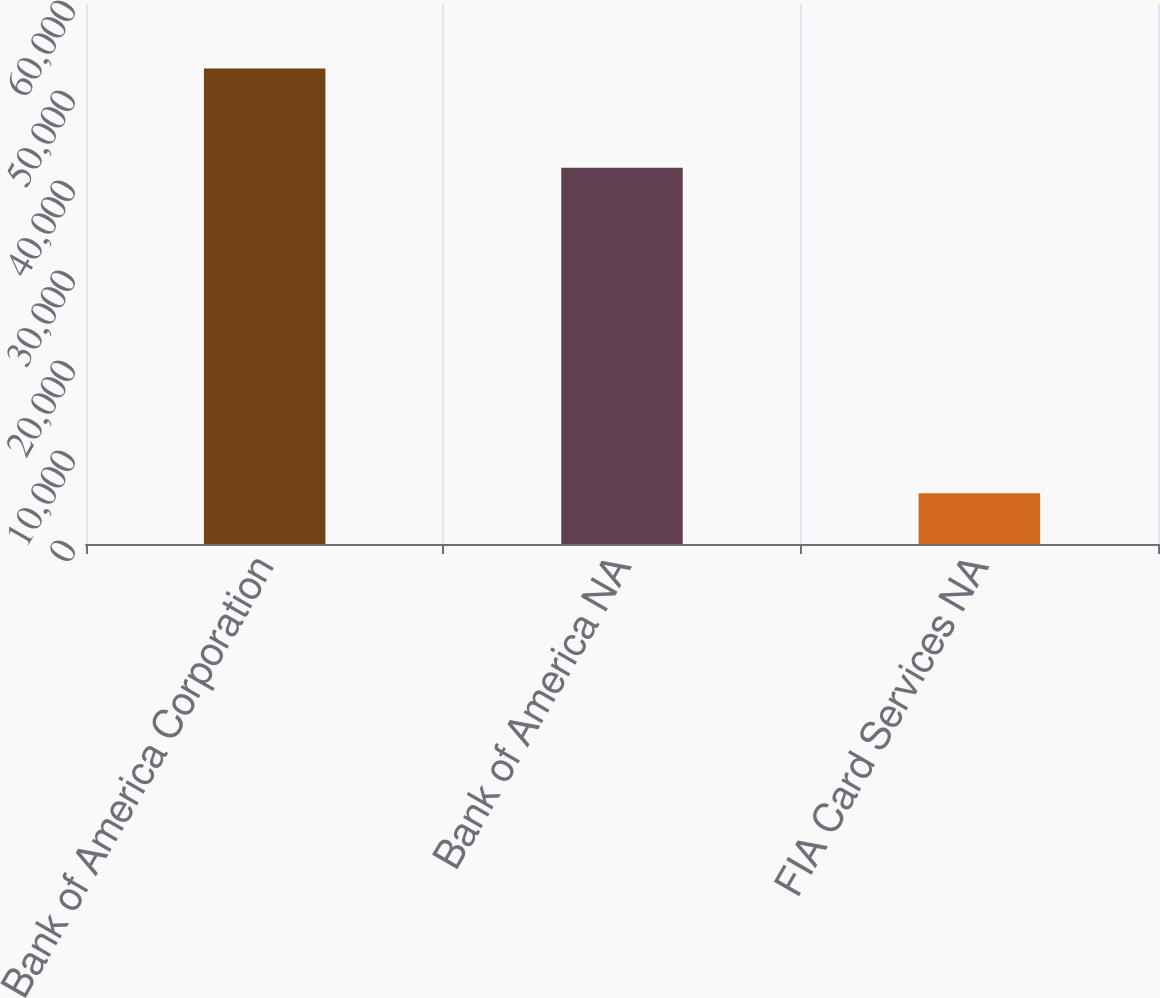Convert chart to OTSL. <chart><loc_0><loc_0><loc_500><loc_500><bar_chart><fcel>Bank of America Corporation<fcel>Bank of America NA<fcel>FIA Card Services NA<nl><fcel>52833<fcel>41818<fcel>5632<nl></chart> 